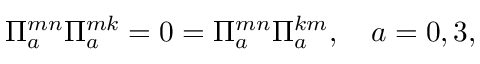Convert formula to latex. <formula><loc_0><loc_0><loc_500><loc_500>\Pi _ { a } ^ { m n } \Pi _ { a } ^ { m k } = 0 = \Pi _ { a } ^ { m n } \Pi _ { a } ^ { k m } , \quad a = 0 , 3 ,</formula> 